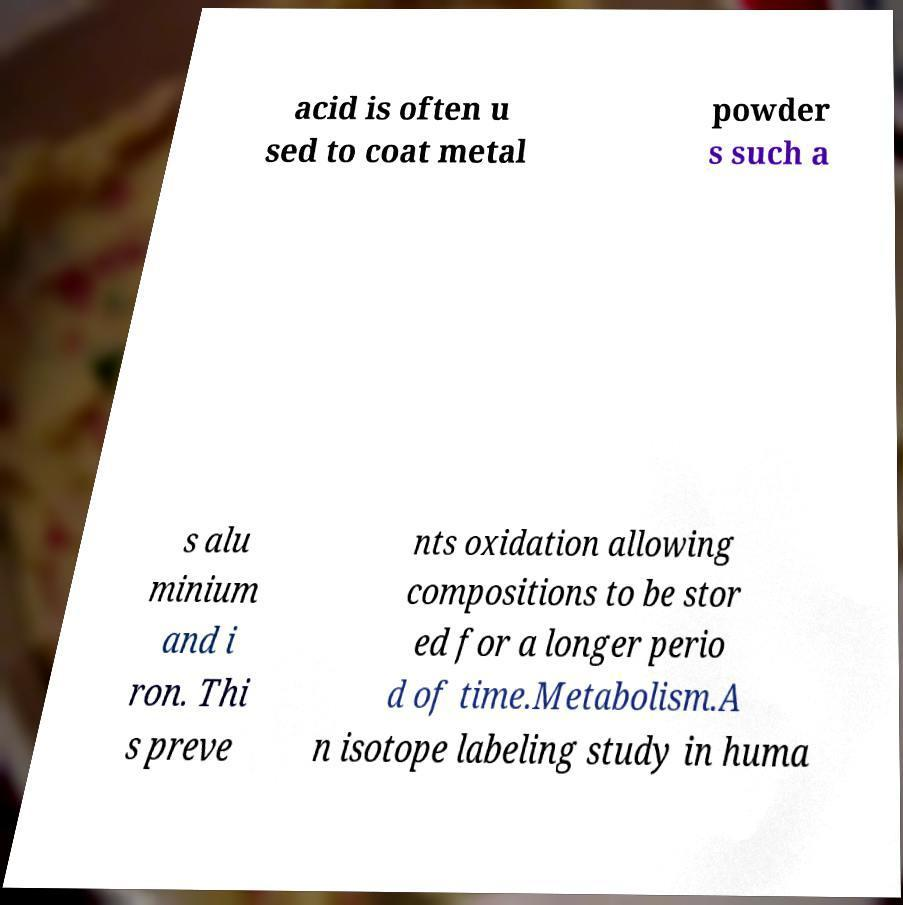Could you extract and type out the text from this image? acid is often u sed to coat metal powder s such a s alu minium and i ron. Thi s preve nts oxidation allowing compositions to be stor ed for a longer perio d of time.Metabolism.A n isotope labeling study in huma 